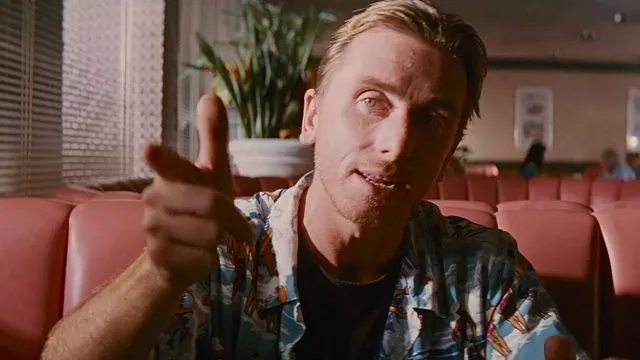What can you infer about the person's demeanor based on their expression and body language? The person's expression and body language communicate a friendly and inviting presence. Their direct gaze and pointed finger, paired with a soft smile, suggest they might be in the midst of a casual conversation or making a light-hearted point. Their relaxed posture with one hand casually resting on the table reinforces this sense of ease and confidence. 